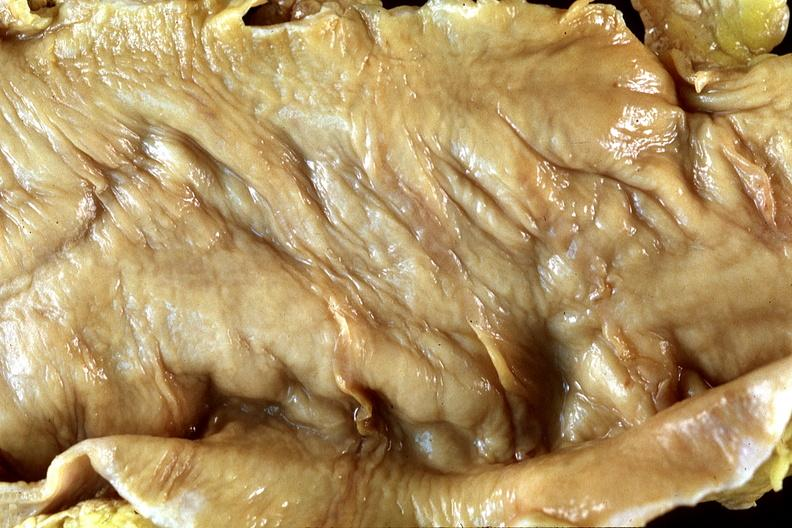where does this belong to?
Answer the question using a single word or phrase. Gastrointestinal system 